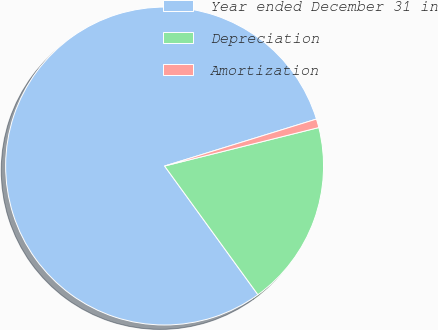Convert chart to OTSL. <chart><loc_0><loc_0><loc_500><loc_500><pie_chart><fcel>Year ended December 31 in<fcel>Depreciation<fcel>Amortization<nl><fcel>80.22%<fcel>18.91%<fcel>0.88%<nl></chart> 